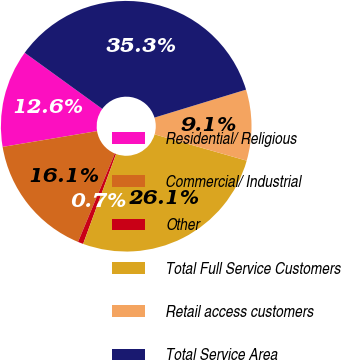Convert chart. <chart><loc_0><loc_0><loc_500><loc_500><pie_chart><fcel>Residential/ Religious<fcel>Commercial/ Industrial<fcel>Other<fcel>Total Full Service Customers<fcel>Retail access customers<fcel>Total Service Area<nl><fcel>12.61%<fcel>16.08%<fcel>0.7%<fcel>26.15%<fcel>9.15%<fcel>35.31%<nl></chart> 